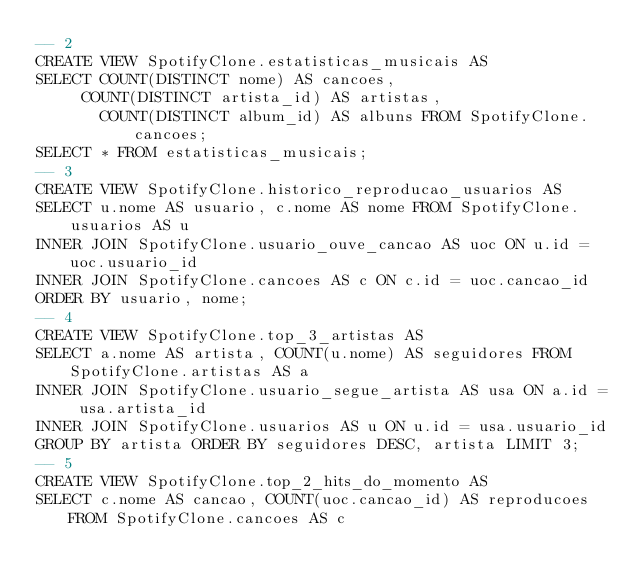<code> <loc_0><loc_0><loc_500><loc_500><_SQL_>-- 2
CREATE VIEW SpotifyClone.estatisticas_musicais AS
SELECT COUNT(DISTINCT nome) AS cancoes,
	   COUNT(DISTINCT artista_id) AS artistas,
       COUNT(DISTINCT album_id) AS albuns FROM SpotifyClone.cancoes;
SELECT * FROM estatisticas_musicais;
-- 3
CREATE VIEW SpotifyClone.historico_reproducao_usuarios AS
SELECT u.nome AS usuario, c.nome AS nome FROM SpotifyClone.usuarios AS u
INNER JOIN SpotifyClone.usuario_ouve_cancao AS uoc ON u.id = uoc.usuario_id
INNER JOIN SpotifyClone.cancoes AS c ON c.id = uoc.cancao_id
ORDER BY usuario, nome;
-- 4
CREATE VIEW SpotifyClone.top_3_artistas AS
SELECT a.nome AS artista, COUNT(u.nome) AS seguidores FROM SpotifyClone.artistas AS a
INNER JOIN SpotifyClone.usuario_segue_artista AS usa ON a.id = usa.artista_id
INNER JOIN SpotifyClone.usuarios AS u ON u.id = usa.usuario_id
GROUP BY artista ORDER BY seguidores DESC, artista LIMIT 3;
-- 5
CREATE VIEW SpotifyClone.top_2_hits_do_momento AS
SELECT c.nome AS cancao, COUNT(uoc.cancao_id) AS reproducoes FROM SpotifyClone.cancoes AS c</code> 